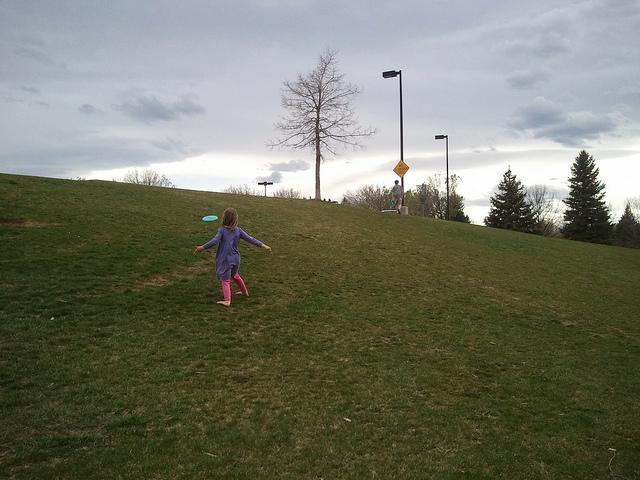How many people do you see?
Give a very brief answer. 2. 